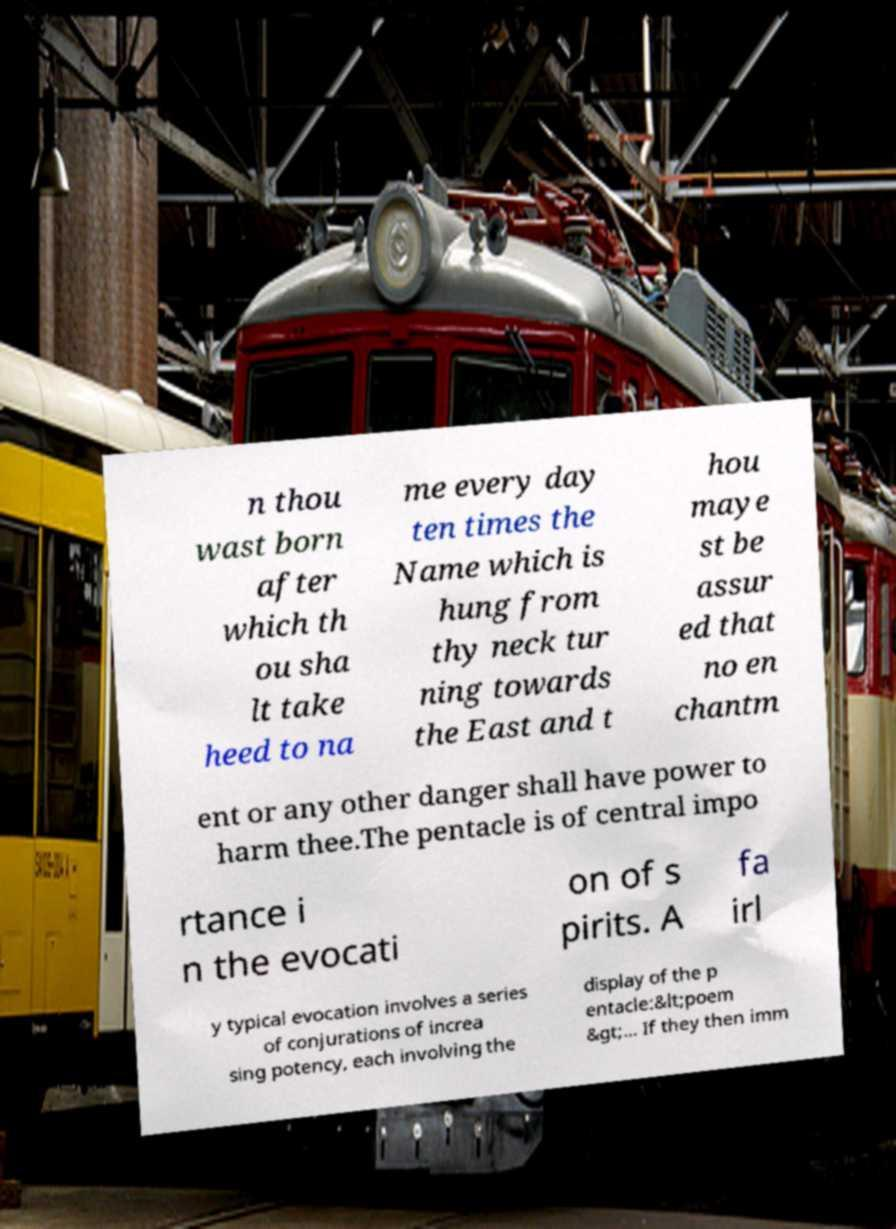Could you extract and type out the text from this image? n thou wast born after which th ou sha lt take heed to na me every day ten times the Name which is hung from thy neck tur ning towards the East and t hou maye st be assur ed that no en chantm ent or any other danger shall have power to harm thee.The pentacle is of central impo rtance i n the evocati on of s pirits. A fa irl y typical evocation involves a series of conjurations of increa sing potency, each involving the display of the p entacle:&lt;poem &gt;... If they then imm 